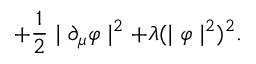Convert formula to latex. <formula><loc_0><loc_0><loc_500><loc_500>+ \frac { 1 } { 2 } | \partial _ { \mu } \varphi | ^ { 2 } + \lambda ( | \varphi | ^ { 2 } ) ^ { 2 } .</formula> 